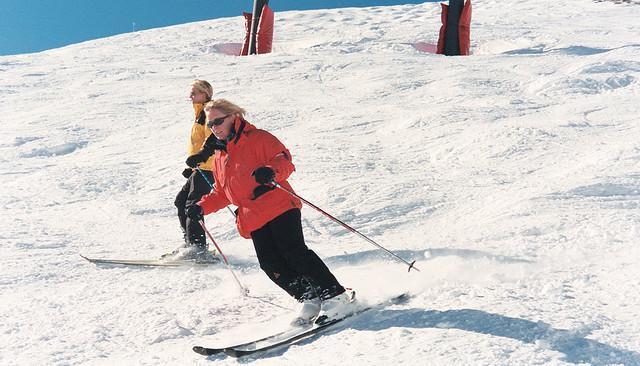How many poles are sticking out the ground?
Give a very brief answer. 2. How many people are in this picture?
Give a very brief answer. 2. How many people are visible?
Give a very brief answer. 2. 